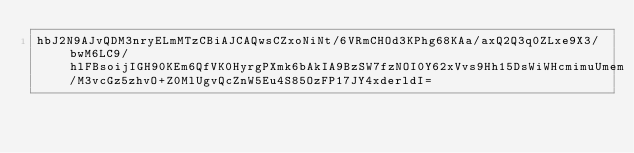Convert code to text. <code><loc_0><loc_0><loc_500><loc_500><_SML_>hbJ2N9AJvQDM3nryELmMTzCBiAJCAQwsCZxoNiNt/6VRmCHOd3KPhg68KAa/axQ2Q3q0ZLxe9X3/bwM6LC9/hlFBsoijIGH90KEm6QfVK0HyrgPXmk6bAkIA9BzSW7fzNOI0Y62xVvs9Hh15DsWiWHcmimuUmem/M3vcGz5zhvO+Z0MlUgvQcZnW5Eu4S85OzFP17JY4xderldI=</code> 